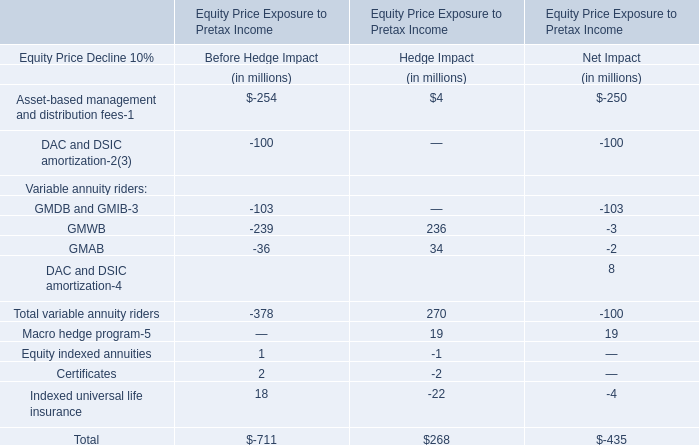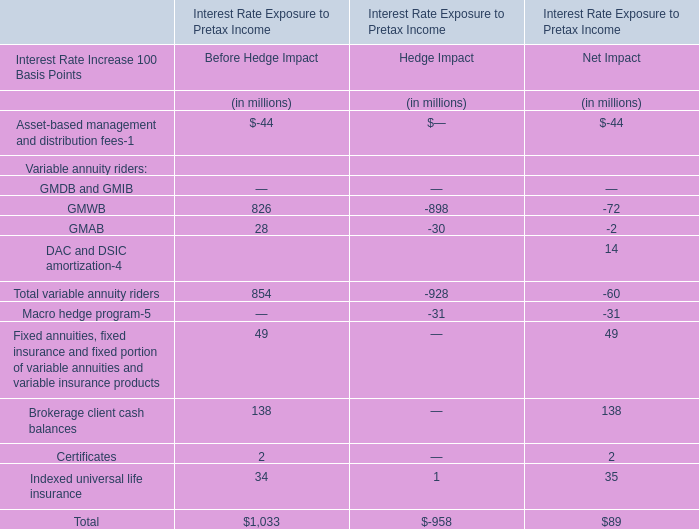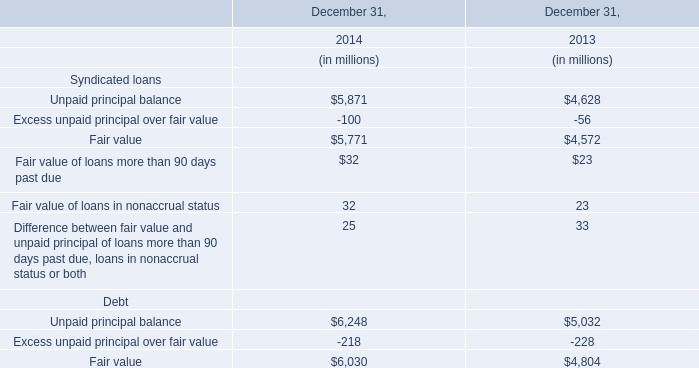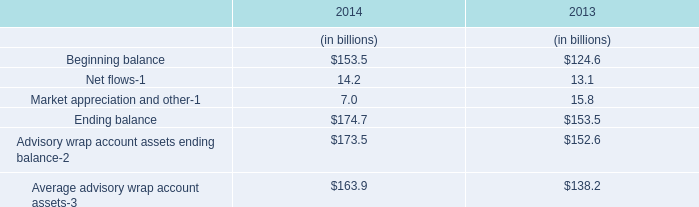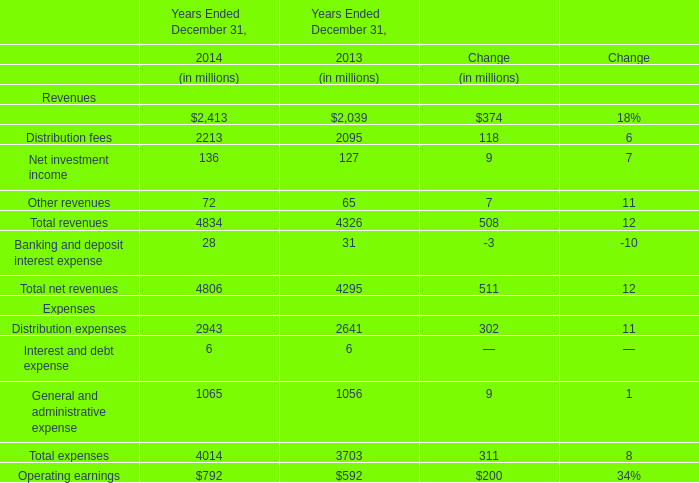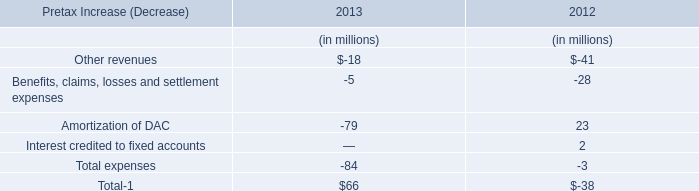What's the greatest value of Ending balance in 2014? (in millions) 
Answer: 174.7. 